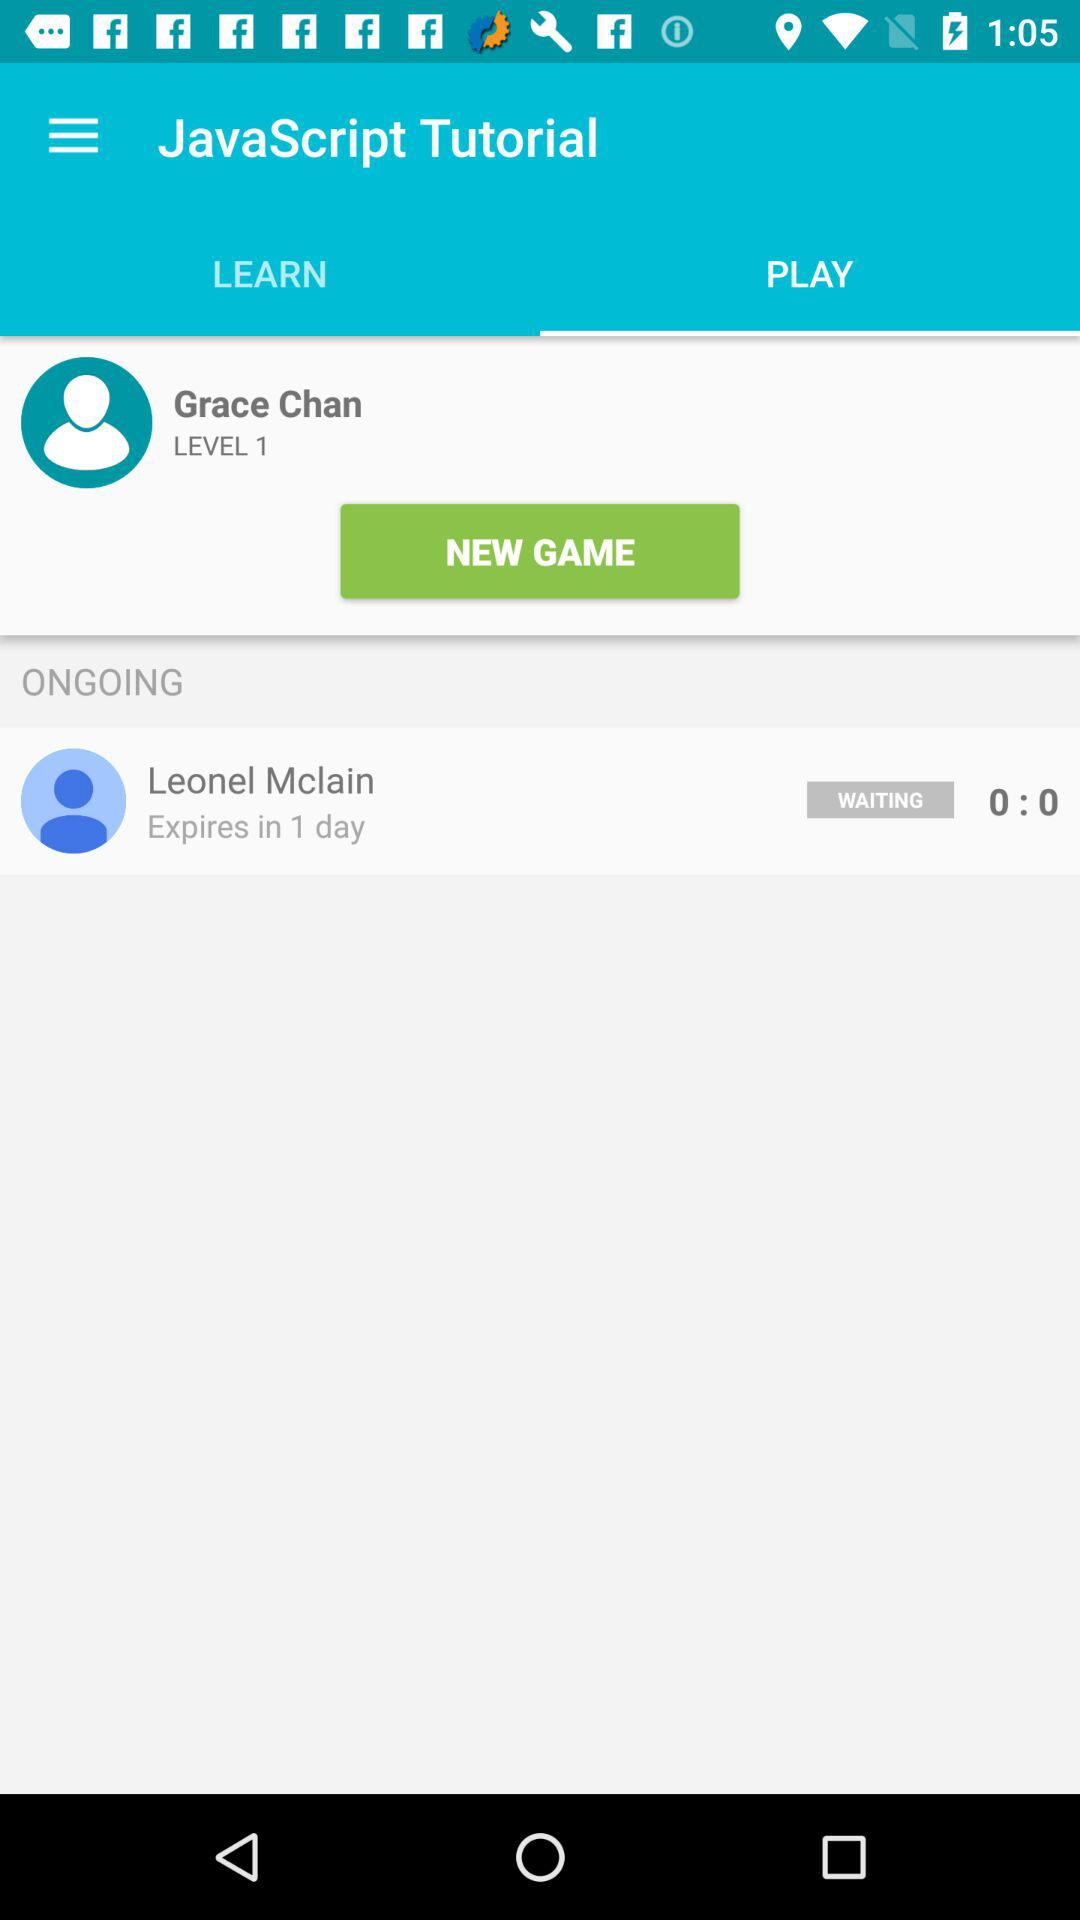What is the name of the user? The name of the user is "Grace Chain". 